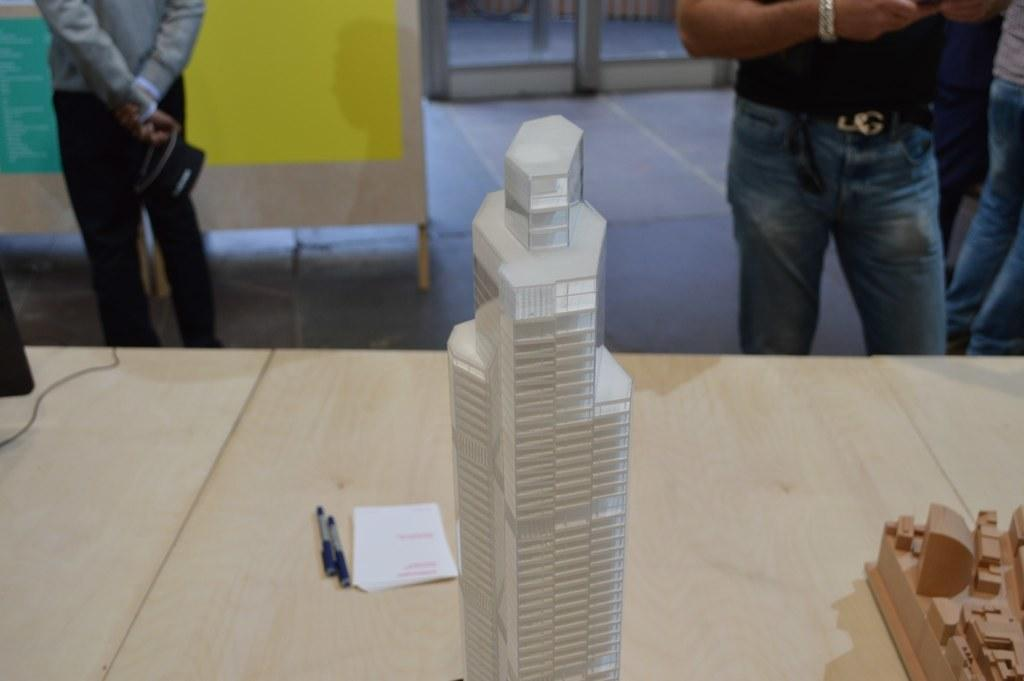What type of building is shown in the image? There is a glass building in the image. Can you describe the person on the right side of the image? A man is standing on the right side of the image, and he is wearing blue trousers. What items can be seen on the table in the image? There are pens and a paper on the table in the image. What number is written on the carriage in the image? There is no carriage present in the image. What historical event is depicted in the image? There is no historical event depicted in the image; it features a glass building, a man, and items on a table. 